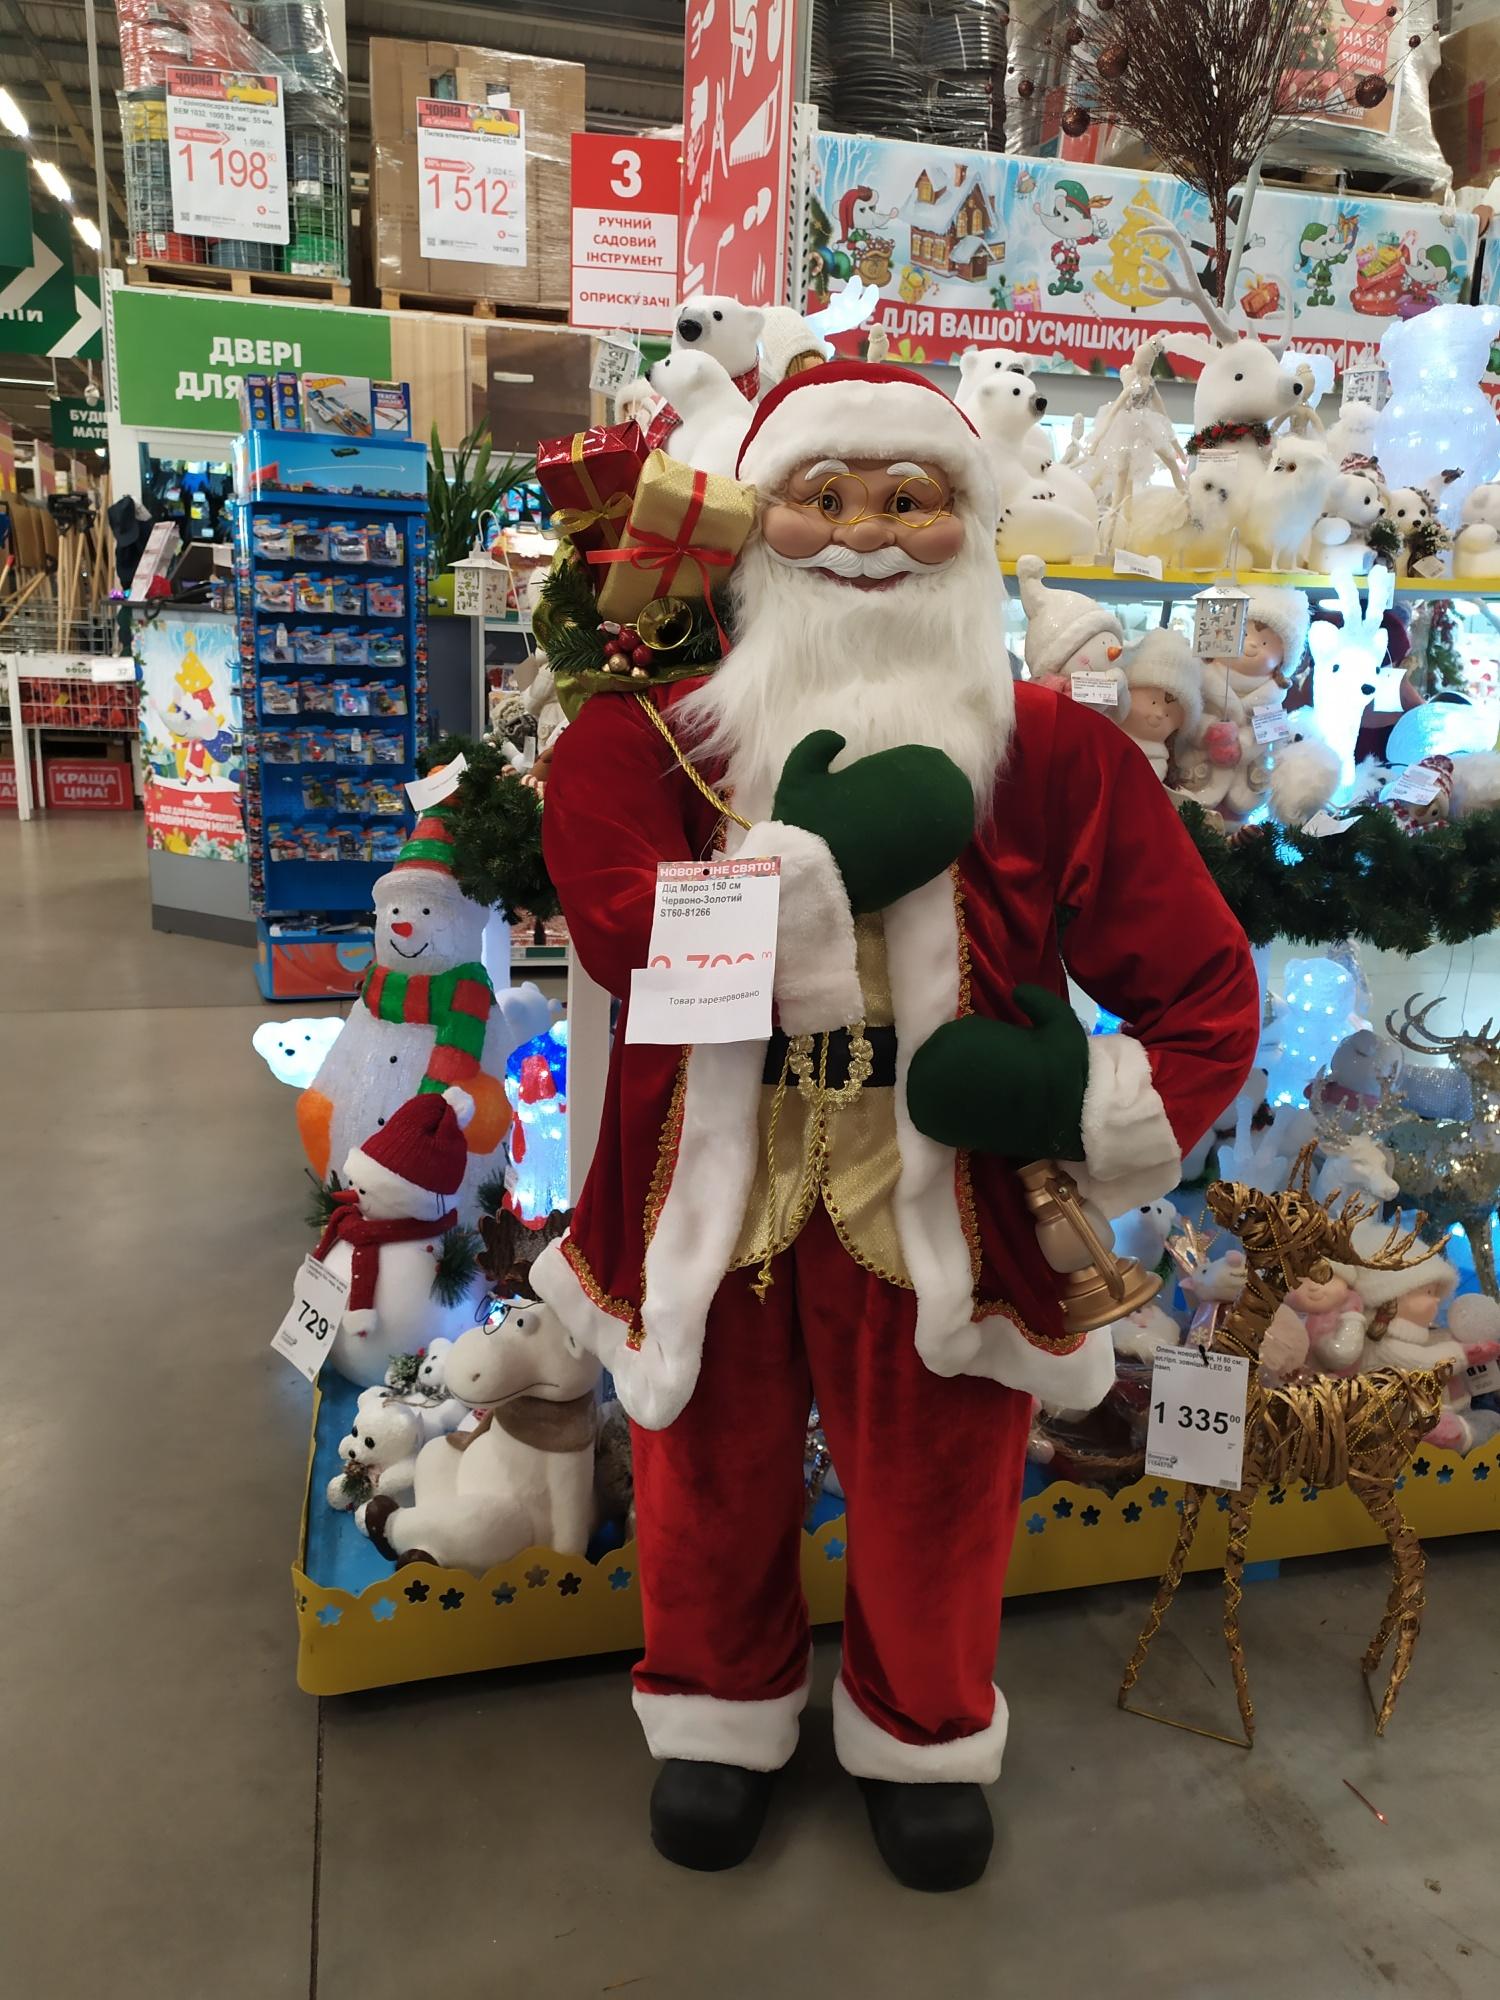Let’s explore the international appeal of this Christmas display. What elements make it appealing globally? This Christmas display has several elements that contribute to its international appeal. Firstly, Santa Claus himself is an iconic figure recognized and beloved worldwide, symbolizing the spirit of Christmas. His presence in the display instantly evokes a sense of festivity and joy. The inscription 'Новый год,' meaning 'New Year' in Russian, highlights the celebration of both Christmas and New Year’s traditions, appealing to diverse cultural backgrounds.

Additionally, the variety of plush toys, such as polar bears and snowmen, and universally recognized symbols like reindeer and Christmas trees, further enhance the global appeal. These elements transcend cultural borders, evoking a sense of shared holiday spirit. The colorful and bright decorations, combined with the elaborate lighting, create a warm and inviting atmosphere that resonates with people across different cultures, making the display a universal source of holiday cheer. What theme would you say this store’s holiday display revolves around? The store's holiday display primarily revolves around the theme of 'Classic Christmas Joy and Global Festivity.' The life-size Santa Claus, the synonymous Christmas characters like snowmen and reindeer, and the vibrant, festive decorations encapsulate the timeless joy associated with Christmas. The inclusion of 'Новый год' reflects the broader celebration of the holiday season, encompassing both Christmas and New Year, thereby adding an international flavor to the display. This theme emphasizes warmth, joy, generosity, and the universal spirit of festive celebration, appealing to a wide audience irrespective of regional or cultural differences. 